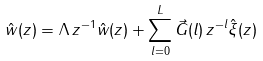Convert formula to latex. <formula><loc_0><loc_0><loc_500><loc_500>\hat { w } ( z ) = \Lambda \, z ^ { - 1 } \hat { w } ( z ) + \sum _ { l = 0 } ^ { L } \vec { G } ( l ) \, z ^ { - l } \hat { \xi } ( z ) \</formula> 